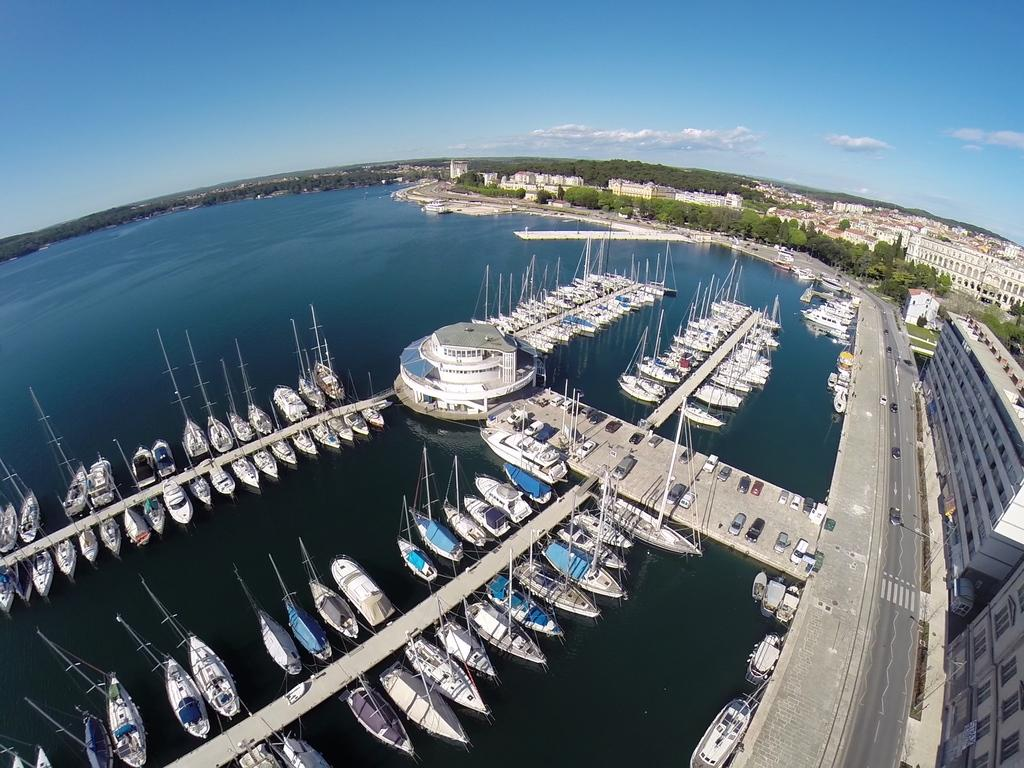What type of natural feature is present in the image? There is a lake in the image. What structures are near the lake? There is a building and a road near the lake. What can be seen in the sky in the image? The sky is visible at the top of the image. What type of vegetation is present in the image? There are trees in the image. What man-made structure is visible in the image? The building is visible in the image. How much does the garden weigh in the image? There is no garden present in the image, so it is not possible to determine its weight. 